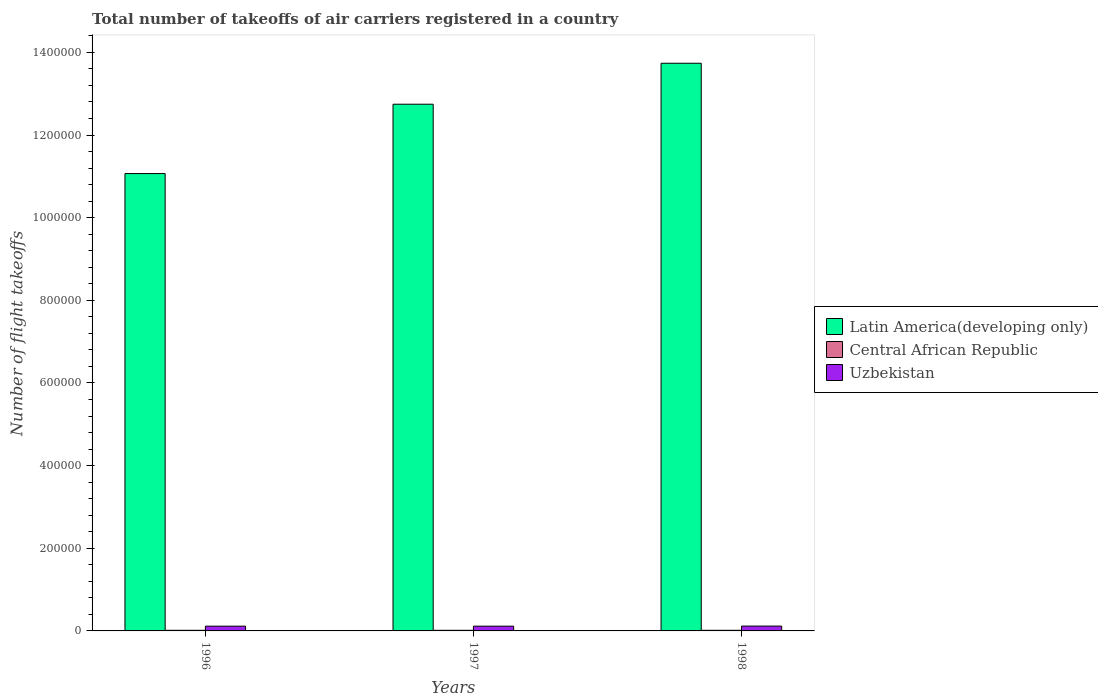How many different coloured bars are there?
Ensure brevity in your answer.  3. How many bars are there on the 2nd tick from the right?
Your response must be concise. 3. What is the total number of flight takeoffs in Uzbekistan in 1997?
Provide a succinct answer. 1.15e+04. Across all years, what is the maximum total number of flight takeoffs in Central African Republic?
Make the answer very short. 1500. Across all years, what is the minimum total number of flight takeoffs in Central African Republic?
Ensure brevity in your answer.  1500. In which year was the total number of flight takeoffs in Uzbekistan maximum?
Offer a terse response. 1998. In which year was the total number of flight takeoffs in Uzbekistan minimum?
Provide a succinct answer. 1996. What is the total total number of flight takeoffs in Latin America(developing only) in the graph?
Your answer should be very brief. 3.75e+06. What is the difference between the total number of flight takeoffs in Central African Republic in 1996 and that in 1998?
Your answer should be compact. 0. What is the difference between the total number of flight takeoffs in Uzbekistan in 1998 and the total number of flight takeoffs in Latin America(developing only) in 1996?
Keep it short and to the point. -1.10e+06. What is the average total number of flight takeoffs in Uzbekistan per year?
Provide a short and direct response. 1.16e+04. In the year 1998, what is the difference between the total number of flight takeoffs in Uzbekistan and total number of flight takeoffs in Latin America(developing only)?
Provide a succinct answer. -1.36e+06. What is the ratio of the total number of flight takeoffs in Latin America(developing only) in 1996 to that in 1998?
Make the answer very short. 0.81. Is the total number of flight takeoffs in Latin America(developing only) in 1996 less than that in 1998?
Your response must be concise. Yes. What is the difference between the highest and the second highest total number of flight takeoffs in Central African Republic?
Provide a short and direct response. 0. Is the sum of the total number of flight takeoffs in Latin America(developing only) in 1996 and 1997 greater than the maximum total number of flight takeoffs in Uzbekistan across all years?
Make the answer very short. Yes. What does the 2nd bar from the left in 1998 represents?
Ensure brevity in your answer.  Central African Republic. What does the 1st bar from the right in 1997 represents?
Keep it short and to the point. Uzbekistan. How many bars are there?
Make the answer very short. 9. Are all the bars in the graph horizontal?
Offer a very short reply. No. How many years are there in the graph?
Offer a very short reply. 3. What is the difference between two consecutive major ticks on the Y-axis?
Your answer should be very brief. 2.00e+05. Are the values on the major ticks of Y-axis written in scientific E-notation?
Your response must be concise. No. Does the graph contain grids?
Your answer should be compact. No. How many legend labels are there?
Offer a terse response. 3. How are the legend labels stacked?
Your answer should be very brief. Vertical. What is the title of the graph?
Offer a terse response. Total number of takeoffs of air carriers registered in a country. What is the label or title of the X-axis?
Offer a very short reply. Years. What is the label or title of the Y-axis?
Give a very brief answer. Number of flight takeoffs. What is the Number of flight takeoffs of Latin America(developing only) in 1996?
Your answer should be very brief. 1.11e+06. What is the Number of flight takeoffs in Central African Republic in 1996?
Offer a terse response. 1500. What is the Number of flight takeoffs in Uzbekistan in 1996?
Your answer should be compact. 1.15e+04. What is the Number of flight takeoffs of Latin America(developing only) in 1997?
Offer a very short reply. 1.27e+06. What is the Number of flight takeoffs in Central African Republic in 1997?
Your response must be concise. 1500. What is the Number of flight takeoffs of Uzbekistan in 1997?
Provide a short and direct response. 1.15e+04. What is the Number of flight takeoffs in Latin America(developing only) in 1998?
Offer a very short reply. 1.37e+06. What is the Number of flight takeoffs in Central African Republic in 1998?
Your answer should be very brief. 1500. What is the Number of flight takeoffs in Uzbekistan in 1998?
Your answer should be very brief. 1.17e+04. Across all years, what is the maximum Number of flight takeoffs of Latin America(developing only)?
Offer a terse response. 1.37e+06. Across all years, what is the maximum Number of flight takeoffs of Central African Republic?
Give a very brief answer. 1500. Across all years, what is the maximum Number of flight takeoffs of Uzbekistan?
Offer a very short reply. 1.17e+04. Across all years, what is the minimum Number of flight takeoffs in Latin America(developing only)?
Provide a succinct answer. 1.11e+06. Across all years, what is the minimum Number of flight takeoffs in Central African Republic?
Provide a succinct answer. 1500. Across all years, what is the minimum Number of flight takeoffs of Uzbekistan?
Ensure brevity in your answer.  1.15e+04. What is the total Number of flight takeoffs in Latin America(developing only) in the graph?
Give a very brief answer. 3.75e+06. What is the total Number of flight takeoffs of Central African Republic in the graph?
Keep it short and to the point. 4500. What is the total Number of flight takeoffs of Uzbekistan in the graph?
Ensure brevity in your answer.  3.47e+04. What is the difference between the Number of flight takeoffs in Latin America(developing only) in 1996 and that in 1997?
Keep it short and to the point. -1.68e+05. What is the difference between the Number of flight takeoffs in Central African Republic in 1996 and that in 1997?
Your answer should be compact. 0. What is the difference between the Number of flight takeoffs in Latin America(developing only) in 1996 and that in 1998?
Offer a terse response. -2.67e+05. What is the difference between the Number of flight takeoffs of Central African Republic in 1996 and that in 1998?
Your response must be concise. 0. What is the difference between the Number of flight takeoffs in Uzbekistan in 1996 and that in 1998?
Provide a short and direct response. -200. What is the difference between the Number of flight takeoffs of Latin America(developing only) in 1997 and that in 1998?
Make the answer very short. -9.91e+04. What is the difference between the Number of flight takeoffs of Central African Republic in 1997 and that in 1998?
Your answer should be compact. 0. What is the difference between the Number of flight takeoffs of Uzbekistan in 1997 and that in 1998?
Offer a terse response. -200. What is the difference between the Number of flight takeoffs of Latin America(developing only) in 1996 and the Number of flight takeoffs of Central African Republic in 1997?
Your response must be concise. 1.11e+06. What is the difference between the Number of flight takeoffs of Latin America(developing only) in 1996 and the Number of flight takeoffs of Uzbekistan in 1997?
Your answer should be very brief. 1.10e+06. What is the difference between the Number of flight takeoffs in Latin America(developing only) in 1996 and the Number of flight takeoffs in Central African Republic in 1998?
Your answer should be compact. 1.11e+06. What is the difference between the Number of flight takeoffs of Latin America(developing only) in 1996 and the Number of flight takeoffs of Uzbekistan in 1998?
Your answer should be very brief. 1.10e+06. What is the difference between the Number of flight takeoffs in Central African Republic in 1996 and the Number of flight takeoffs in Uzbekistan in 1998?
Provide a short and direct response. -1.02e+04. What is the difference between the Number of flight takeoffs of Latin America(developing only) in 1997 and the Number of flight takeoffs of Central African Republic in 1998?
Make the answer very short. 1.27e+06. What is the difference between the Number of flight takeoffs in Latin America(developing only) in 1997 and the Number of flight takeoffs in Uzbekistan in 1998?
Your response must be concise. 1.26e+06. What is the difference between the Number of flight takeoffs of Central African Republic in 1997 and the Number of flight takeoffs of Uzbekistan in 1998?
Offer a terse response. -1.02e+04. What is the average Number of flight takeoffs of Latin America(developing only) per year?
Your answer should be compact. 1.25e+06. What is the average Number of flight takeoffs of Central African Republic per year?
Keep it short and to the point. 1500. What is the average Number of flight takeoffs in Uzbekistan per year?
Give a very brief answer. 1.16e+04. In the year 1996, what is the difference between the Number of flight takeoffs of Latin America(developing only) and Number of flight takeoffs of Central African Republic?
Offer a terse response. 1.11e+06. In the year 1996, what is the difference between the Number of flight takeoffs in Latin America(developing only) and Number of flight takeoffs in Uzbekistan?
Give a very brief answer. 1.10e+06. In the year 1997, what is the difference between the Number of flight takeoffs in Latin America(developing only) and Number of flight takeoffs in Central African Republic?
Make the answer very short. 1.27e+06. In the year 1997, what is the difference between the Number of flight takeoffs in Latin America(developing only) and Number of flight takeoffs in Uzbekistan?
Your response must be concise. 1.26e+06. In the year 1997, what is the difference between the Number of flight takeoffs of Central African Republic and Number of flight takeoffs of Uzbekistan?
Provide a short and direct response. -10000. In the year 1998, what is the difference between the Number of flight takeoffs of Latin America(developing only) and Number of flight takeoffs of Central African Republic?
Ensure brevity in your answer.  1.37e+06. In the year 1998, what is the difference between the Number of flight takeoffs in Latin America(developing only) and Number of flight takeoffs in Uzbekistan?
Provide a succinct answer. 1.36e+06. In the year 1998, what is the difference between the Number of flight takeoffs of Central African Republic and Number of flight takeoffs of Uzbekistan?
Keep it short and to the point. -1.02e+04. What is the ratio of the Number of flight takeoffs of Latin America(developing only) in 1996 to that in 1997?
Your response must be concise. 0.87. What is the ratio of the Number of flight takeoffs in Central African Republic in 1996 to that in 1997?
Your answer should be very brief. 1. What is the ratio of the Number of flight takeoffs of Latin America(developing only) in 1996 to that in 1998?
Give a very brief answer. 0.81. What is the ratio of the Number of flight takeoffs of Uzbekistan in 1996 to that in 1998?
Keep it short and to the point. 0.98. What is the ratio of the Number of flight takeoffs of Latin America(developing only) in 1997 to that in 1998?
Provide a succinct answer. 0.93. What is the ratio of the Number of flight takeoffs of Central African Republic in 1997 to that in 1998?
Provide a succinct answer. 1. What is the ratio of the Number of flight takeoffs in Uzbekistan in 1997 to that in 1998?
Give a very brief answer. 0.98. What is the difference between the highest and the second highest Number of flight takeoffs in Latin America(developing only)?
Provide a succinct answer. 9.91e+04. What is the difference between the highest and the second highest Number of flight takeoffs in Central African Republic?
Your answer should be very brief. 0. What is the difference between the highest and the second highest Number of flight takeoffs of Uzbekistan?
Your response must be concise. 200. What is the difference between the highest and the lowest Number of flight takeoffs of Latin America(developing only)?
Give a very brief answer. 2.67e+05. What is the difference between the highest and the lowest Number of flight takeoffs of Uzbekistan?
Keep it short and to the point. 200. 